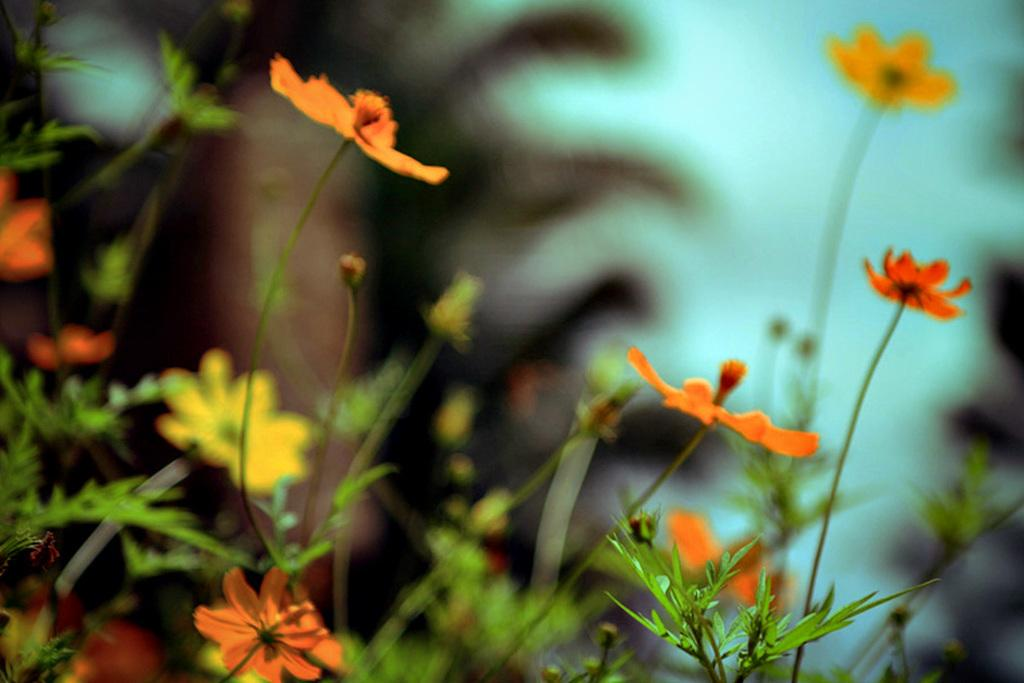What type of plants are visible in the image? There are plants with flowers in the image. Can you describe the background of the image? The background of the image is blurred. Can you see a zebra among the plants in the image? There is no zebra present among the plants in the image. Do the plants in the image appear to be in pain? The image does not provide any information about the plants' condition or whether they are in pain. Are the plants in the image stretching out their leaves? The image does not provide any information about the plants' movements or whether they are stretching out their leaves. 